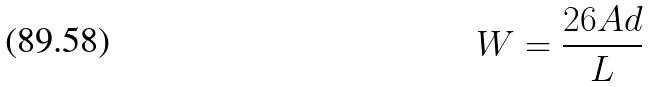<formula> <loc_0><loc_0><loc_500><loc_500>W = \frac { 2 6 A d } { L }</formula> 